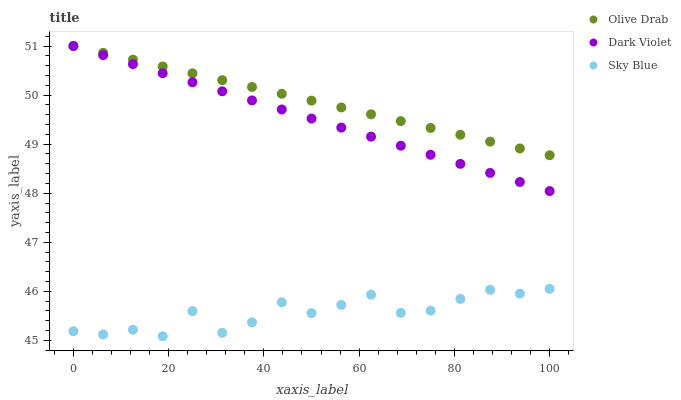Does Sky Blue have the minimum area under the curve?
Answer yes or no. Yes. Does Olive Drab have the maximum area under the curve?
Answer yes or no. Yes. Does Dark Violet have the minimum area under the curve?
Answer yes or no. No. Does Dark Violet have the maximum area under the curve?
Answer yes or no. No. Is Dark Violet the smoothest?
Answer yes or no. Yes. Is Sky Blue the roughest?
Answer yes or no. Yes. Is Olive Drab the smoothest?
Answer yes or no. No. Is Olive Drab the roughest?
Answer yes or no. No. Does Sky Blue have the lowest value?
Answer yes or no. Yes. Does Dark Violet have the lowest value?
Answer yes or no. No. Does Olive Drab have the highest value?
Answer yes or no. Yes. Is Sky Blue less than Olive Drab?
Answer yes or no. Yes. Is Olive Drab greater than Sky Blue?
Answer yes or no. Yes. Does Dark Violet intersect Olive Drab?
Answer yes or no. Yes. Is Dark Violet less than Olive Drab?
Answer yes or no. No. Is Dark Violet greater than Olive Drab?
Answer yes or no. No. Does Sky Blue intersect Olive Drab?
Answer yes or no. No. 